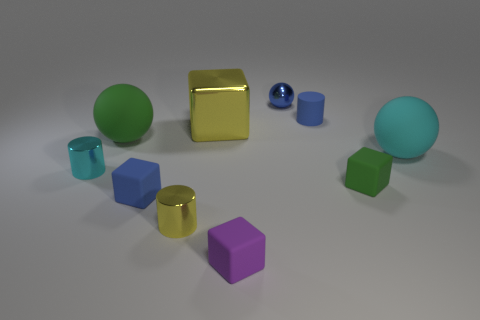Does the big cube have the same material as the ball behind the large shiny block?
Your response must be concise. Yes. The other rubber sphere that is the same size as the green sphere is what color?
Your response must be concise. Cyan. What is the size of the cube that is behind the green object behind the cyan shiny thing?
Offer a terse response. Large. Do the tiny ball and the rubber block that is right of the tiny metallic sphere have the same color?
Offer a terse response. No. Is the number of cyan metal cylinders that are in front of the blue block less than the number of tiny green blocks?
Keep it short and to the point. Yes. How many other objects are the same size as the green matte block?
Give a very brief answer. 6. There is a green thing right of the small yellow shiny object; is its shape the same as the small purple thing?
Ensure brevity in your answer.  Yes. Are there more blue matte things that are behind the large yellow metallic thing than tiny green shiny balls?
Offer a very short reply. Yes. There is a sphere that is both in front of the large metal object and left of the cyan matte sphere; what material is it made of?
Keep it short and to the point. Rubber. What number of rubber things are behind the large green rubber thing and in front of the yellow block?
Give a very brief answer. 0. 